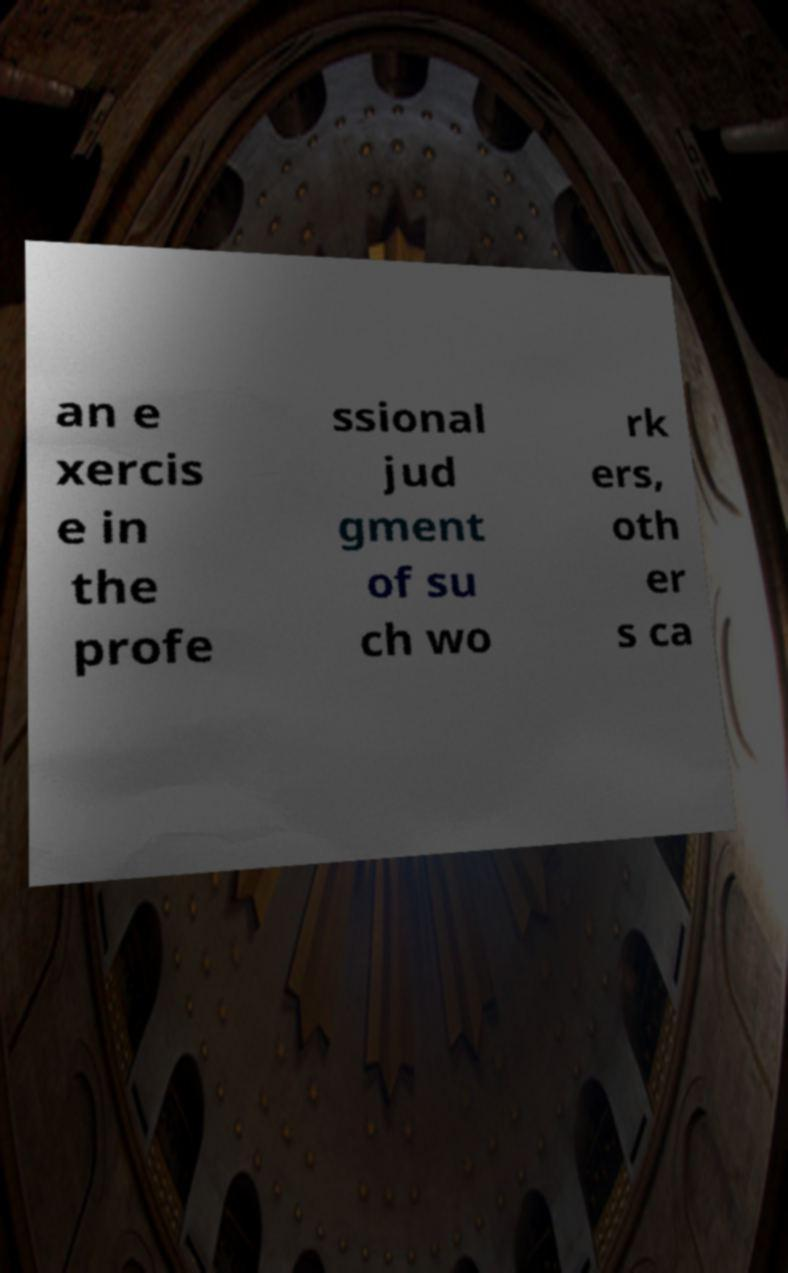Can you read and provide the text displayed in the image?This photo seems to have some interesting text. Can you extract and type it out for me? an e xercis e in the profe ssional jud gment of su ch wo rk ers, oth er s ca 